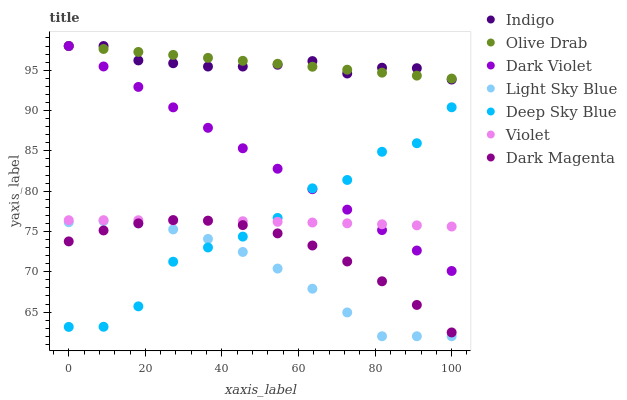Does Light Sky Blue have the minimum area under the curve?
Answer yes or no. Yes. Does Olive Drab have the maximum area under the curve?
Answer yes or no. Yes. Does Dark Magenta have the minimum area under the curve?
Answer yes or no. No. Does Dark Magenta have the maximum area under the curve?
Answer yes or no. No. Is Dark Violet the smoothest?
Answer yes or no. Yes. Is Deep Sky Blue the roughest?
Answer yes or no. Yes. Is Dark Magenta the smoothest?
Answer yes or no. No. Is Dark Magenta the roughest?
Answer yes or no. No. Does Light Sky Blue have the lowest value?
Answer yes or no. Yes. Does Dark Magenta have the lowest value?
Answer yes or no. No. Does Olive Drab have the highest value?
Answer yes or no. Yes. Does Dark Magenta have the highest value?
Answer yes or no. No. Is Light Sky Blue less than Olive Drab?
Answer yes or no. Yes. Is Dark Violet greater than Light Sky Blue?
Answer yes or no. Yes. Does Dark Violet intersect Deep Sky Blue?
Answer yes or no. Yes. Is Dark Violet less than Deep Sky Blue?
Answer yes or no. No. Is Dark Violet greater than Deep Sky Blue?
Answer yes or no. No. Does Light Sky Blue intersect Olive Drab?
Answer yes or no. No. 